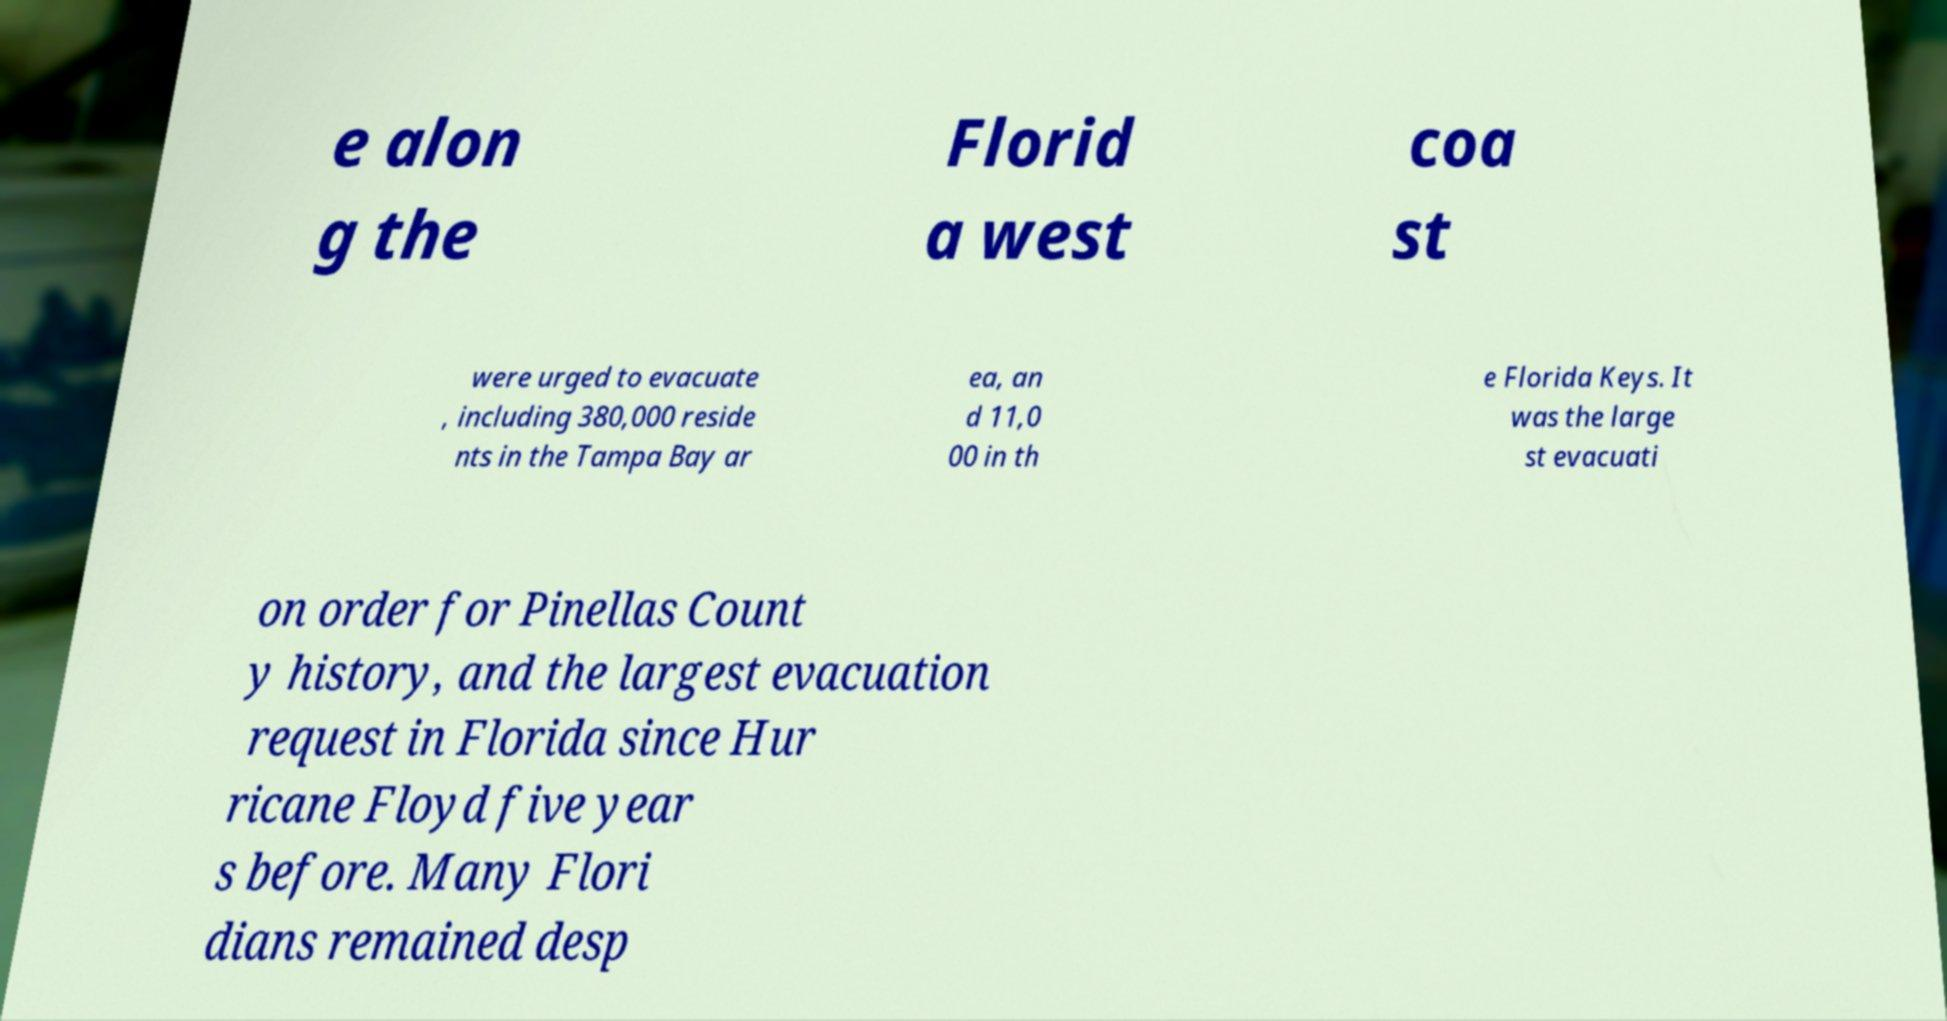For documentation purposes, I need the text within this image transcribed. Could you provide that? e alon g the Florid a west coa st were urged to evacuate , including 380,000 reside nts in the Tampa Bay ar ea, an d 11,0 00 in th e Florida Keys. It was the large st evacuati on order for Pinellas Count y history, and the largest evacuation request in Florida since Hur ricane Floyd five year s before. Many Flori dians remained desp 